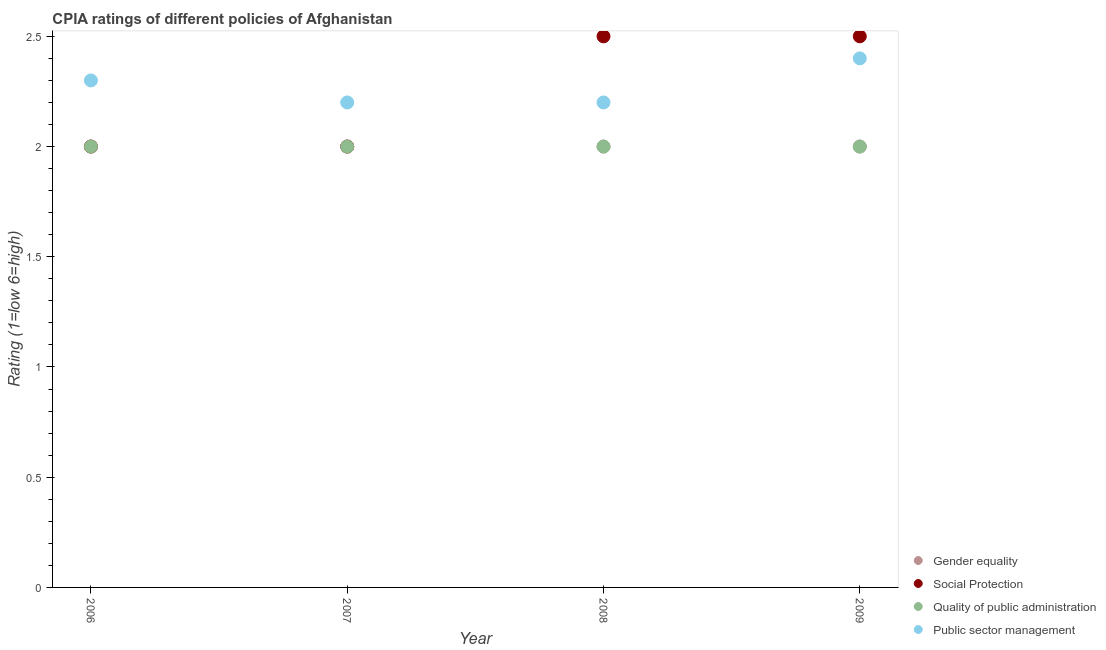How many different coloured dotlines are there?
Keep it short and to the point. 4. Across all years, what is the maximum cpia rating of social protection?
Make the answer very short. 2.5. Across all years, what is the minimum cpia rating of gender equality?
Give a very brief answer. 2. What is the difference between the cpia rating of gender equality in 2007 and the cpia rating of social protection in 2009?
Your response must be concise. -0.5. What is the average cpia rating of public sector management per year?
Provide a succinct answer. 2.27. In the year 2008, what is the difference between the cpia rating of gender equality and cpia rating of public sector management?
Your answer should be compact. -0.2. In how many years, is the cpia rating of social protection greater than 1.3?
Offer a terse response. 4. Is the cpia rating of quality of public administration in 2006 less than that in 2008?
Give a very brief answer. No. What is the difference between the highest and the second highest cpia rating of quality of public administration?
Ensure brevity in your answer.  0. What is the difference between the highest and the lowest cpia rating of public sector management?
Make the answer very short. 0.2. In how many years, is the cpia rating of gender equality greater than the average cpia rating of gender equality taken over all years?
Make the answer very short. 0. Is the sum of the cpia rating of social protection in 2006 and 2009 greater than the maximum cpia rating of public sector management across all years?
Give a very brief answer. Yes. Is it the case that in every year, the sum of the cpia rating of quality of public administration and cpia rating of gender equality is greater than the sum of cpia rating of public sector management and cpia rating of social protection?
Your answer should be compact. No. Does the cpia rating of social protection monotonically increase over the years?
Keep it short and to the point. No. How many years are there in the graph?
Provide a succinct answer. 4. What is the difference between two consecutive major ticks on the Y-axis?
Offer a terse response. 0.5. How many legend labels are there?
Ensure brevity in your answer.  4. How are the legend labels stacked?
Your answer should be compact. Vertical. What is the title of the graph?
Give a very brief answer. CPIA ratings of different policies of Afghanistan. What is the label or title of the X-axis?
Ensure brevity in your answer.  Year. What is the label or title of the Y-axis?
Your answer should be compact. Rating (1=low 6=high). What is the Rating (1=low 6=high) of Social Protection in 2006?
Your answer should be compact. 2. What is the Rating (1=low 6=high) of Quality of public administration in 2006?
Offer a very short reply. 2. What is the Rating (1=low 6=high) of Gender equality in 2007?
Offer a terse response. 2. What is the Rating (1=low 6=high) in Social Protection in 2007?
Provide a succinct answer. 2. What is the Rating (1=low 6=high) in Quality of public administration in 2008?
Provide a succinct answer. 2. What is the Rating (1=low 6=high) in Gender equality in 2009?
Your answer should be compact. 2. What is the Rating (1=low 6=high) of Quality of public administration in 2009?
Your answer should be very brief. 2. Across all years, what is the maximum Rating (1=low 6=high) of Gender equality?
Offer a very short reply. 2. Across all years, what is the maximum Rating (1=low 6=high) in Social Protection?
Provide a short and direct response. 2.5. Across all years, what is the maximum Rating (1=low 6=high) in Public sector management?
Your answer should be very brief. 2.4. Across all years, what is the minimum Rating (1=low 6=high) of Gender equality?
Make the answer very short. 2. Across all years, what is the minimum Rating (1=low 6=high) in Social Protection?
Ensure brevity in your answer.  2. What is the total Rating (1=low 6=high) in Gender equality in the graph?
Your answer should be very brief. 8. What is the difference between the Rating (1=low 6=high) of Public sector management in 2006 and that in 2007?
Offer a very short reply. 0.1. What is the difference between the Rating (1=low 6=high) of Gender equality in 2006 and that in 2008?
Keep it short and to the point. 0. What is the difference between the Rating (1=low 6=high) in Social Protection in 2006 and that in 2008?
Offer a very short reply. -0.5. What is the difference between the Rating (1=low 6=high) in Quality of public administration in 2006 and that in 2008?
Provide a succinct answer. 0. What is the difference between the Rating (1=low 6=high) of Public sector management in 2006 and that in 2008?
Ensure brevity in your answer.  0.1. What is the difference between the Rating (1=low 6=high) of Social Protection in 2006 and that in 2009?
Offer a terse response. -0.5. What is the difference between the Rating (1=low 6=high) of Public sector management in 2006 and that in 2009?
Provide a short and direct response. -0.1. What is the difference between the Rating (1=low 6=high) in Quality of public administration in 2007 and that in 2008?
Provide a short and direct response. 0. What is the difference between the Rating (1=low 6=high) in Gender equality in 2008 and that in 2009?
Keep it short and to the point. 0. What is the difference between the Rating (1=low 6=high) in Social Protection in 2008 and that in 2009?
Provide a succinct answer. 0. What is the difference between the Rating (1=low 6=high) of Quality of public administration in 2008 and that in 2009?
Provide a short and direct response. 0. What is the difference between the Rating (1=low 6=high) in Public sector management in 2008 and that in 2009?
Offer a very short reply. -0.2. What is the difference between the Rating (1=low 6=high) of Social Protection in 2006 and the Rating (1=low 6=high) of Public sector management in 2007?
Your answer should be very brief. -0.2. What is the difference between the Rating (1=low 6=high) of Gender equality in 2006 and the Rating (1=low 6=high) of Quality of public administration in 2008?
Make the answer very short. 0. What is the difference between the Rating (1=low 6=high) in Gender equality in 2006 and the Rating (1=low 6=high) in Public sector management in 2008?
Your answer should be compact. -0.2. What is the difference between the Rating (1=low 6=high) of Social Protection in 2006 and the Rating (1=low 6=high) of Quality of public administration in 2008?
Give a very brief answer. 0. What is the difference between the Rating (1=low 6=high) of Social Protection in 2006 and the Rating (1=low 6=high) of Public sector management in 2008?
Keep it short and to the point. -0.2. What is the difference between the Rating (1=low 6=high) of Quality of public administration in 2006 and the Rating (1=low 6=high) of Public sector management in 2008?
Your response must be concise. -0.2. What is the difference between the Rating (1=low 6=high) of Gender equality in 2006 and the Rating (1=low 6=high) of Public sector management in 2009?
Your answer should be compact. -0.4. What is the difference between the Rating (1=low 6=high) of Social Protection in 2006 and the Rating (1=low 6=high) of Quality of public administration in 2009?
Your answer should be compact. 0. What is the difference between the Rating (1=low 6=high) in Gender equality in 2007 and the Rating (1=low 6=high) in Quality of public administration in 2008?
Provide a short and direct response. 0. What is the difference between the Rating (1=low 6=high) of Gender equality in 2007 and the Rating (1=low 6=high) of Public sector management in 2008?
Your response must be concise. -0.2. What is the difference between the Rating (1=low 6=high) in Social Protection in 2007 and the Rating (1=low 6=high) in Quality of public administration in 2008?
Provide a succinct answer. 0. What is the difference between the Rating (1=low 6=high) in Social Protection in 2007 and the Rating (1=low 6=high) in Public sector management in 2008?
Your answer should be very brief. -0.2. What is the difference between the Rating (1=low 6=high) in Gender equality in 2007 and the Rating (1=low 6=high) in Public sector management in 2009?
Make the answer very short. -0.4. What is the difference between the Rating (1=low 6=high) of Gender equality in 2008 and the Rating (1=low 6=high) of Social Protection in 2009?
Your answer should be very brief. -0.5. What is the difference between the Rating (1=low 6=high) of Gender equality in 2008 and the Rating (1=low 6=high) of Quality of public administration in 2009?
Ensure brevity in your answer.  0. What is the difference between the Rating (1=low 6=high) of Social Protection in 2008 and the Rating (1=low 6=high) of Quality of public administration in 2009?
Your answer should be very brief. 0.5. What is the difference between the Rating (1=low 6=high) of Social Protection in 2008 and the Rating (1=low 6=high) of Public sector management in 2009?
Make the answer very short. 0.1. What is the average Rating (1=low 6=high) of Gender equality per year?
Offer a very short reply. 2. What is the average Rating (1=low 6=high) in Social Protection per year?
Offer a very short reply. 2.25. What is the average Rating (1=low 6=high) in Quality of public administration per year?
Make the answer very short. 2. What is the average Rating (1=low 6=high) in Public sector management per year?
Keep it short and to the point. 2.27. In the year 2006, what is the difference between the Rating (1=low 6=high) in Gender equality and Rating (1=low 6=high) in Quality of public administration?
Your answer should be very brief. 0. In the year 2006, what is the difference between the Rating (1=low 6=high) of Gender equality and Rating (1=low 6=high) of Public sector management?
Your response must be concise. -0.3. In the year 2006, what is the difference between the Rating (1=low 6=high) in Social Protection and Rating (1=low 6=high) in Quality of public administration?
Ensure brevity in your answer.  0. In the year 2006, what is the difference between the Rating (1=low 6=high) of Social Protection and Rating (1=low 6=high) of Public sector management?
Make the answer very short. -0.3. In the year 2006, what is the difference between the Rating (1=low 6=high) of Quality of public administration and Rating (1=low 6=high) of Public sector management?
Ensure brevity in your answer.  -0.3. In the year 2007, what is the difference between the Rating (1=low 6=high) of Social Protection and Rating (1=low 6=high) of Quality of public administration?
Your answer should be compact. 0. In the year 2007, what is the difference between the Rating (1=low 6=high) in Social Protection and Rating (1=low 6=high) in Public sector management?
Offer a very short reply. -0.2. In the year 2007, what is the difference between the Rating (1=low 6=high) of Quality of public administration and Rating (1=low 6=high) of Public sector management?
Give a very brief answer. -0.2. In the year 2008, what is the difference between the Rating (1=low 6=high) of Gender equality and Rating (1=low 6=high) of Social Protection?
Provide a short and direct response. -0.5. In the year 2008, what is the difference between the Rating (1=low 6=high) in Gender equality and Rating (1=low 6=high) in Quality of public administration?
Ensure brevity in your answer.  0. In the year 2008, what is the difference between the Rating (1=low 6=high) of Social Protection and Rating (1=low 6=high) of Public sector management?
Provide a succinct answer. 0.3. In the year 2009, what is the difference between the Rating (1=low 6=high) in Gender equality and Rating (1=low 6=high) in Quality of public administration?
Offer a terse response. 0. In the year 2009, what is the difference between the Rating (1=low 6=high) of Social Protection and Rating (1=low 6=high) of Quality of public administration?
Your response must be concise. 0.5. In the year 2009, what is the difference between the Rating (1=low 6=high) of Social Protection and Rating (1=low 6=high) of Public sector management?
Offer a terse response. 0.1. What is the ratio of the Rating (1=low 6=high) of Gender equality in 2006 to that in 2007?
Provide a succinct answer. 1. What is the ratio of the Rating (1=low 6=high) of Quality of public administration in 2006 to that in 2007?
Provide a succinct answer. 1. What is the ratio of the Rating (1=low 6=high) in Public sector management in 2006 to that in 2007?
Offer a terse response. 1.05. What is the ratio of the Rating (1=low 6=high) of Social Protection in 2006 to that in 2008?
Ensure brevity in your answer.  0.8. What is the ratio of the Rating (1=low 6=high) of Public sector management in 2006 to that in 2008?
Your answer should be compact. 1.05. What is the ratio of the Rating (1=low 6=high) in Quality of public administration in 2006 to that in 2009?
Offer a terse response. 1. What is the ratio of the Rating (1=low 6=high) of Public sector management in 2006 to that in 2009?
Provide a short and direct response. 0.96. What is the ratio of the Rating (1=low 6=high) of Gender equality in 2007 to that in 2008?
Offer a very short reply. 1. What is the ratio of the Rating (1=low 6=high) in Social Protection in 2007 to that in 2008?
Provide a succinct answer. 0.8. What is the ratio of the Rating (1=low 6=high) of Public sector management in 2007 to that in 2008?
Provide a short and direct response. 1. What is the ratio of the Rating (1=low 6=high) in Gender equality in 2007 to that in 2009?
Provide a short and direct response. 1. What is the ratio of the Rating (1=low 6=high) of Quality of public administration in 2007 to that in 2009?
Your answer should be compact. 1. What is the ratio of the Rating (1=low 6=high) in Gender equality in 2008 to that in 2009?
Offer a terse response. 1. What is the ratio of the Rating (1=low 6=high) of Public sector management in 2008 to that in 2009?
Provide a succinct answer. 0.92. What is the difference between the highest and the second highest Rating (1=low 6=high) in Gender equality?
Your answer should be very brief. 0. What is the difference between the highest and the second highest Rating (1=low 6=high) in Social Protection?
Offer a terse response. 0. What is the difference between the highest and the second highest Rating (1=low 6=high) in Public sector management?
Your response must be concise. 0.1. What is the difference between the highest and the lowest Rating (1=low 6=high) of Gender equality?
Your answer should be very brief. 0. What is the difference between the highest and the lowest Rating (1=low 6=high) in Quality of public administration?
Your answer should be very brief. 0. What is the difference between the highest and the lowest Rating (1=low 6=high) of Public sector management?
Provide a succinct answer. 0.2. 